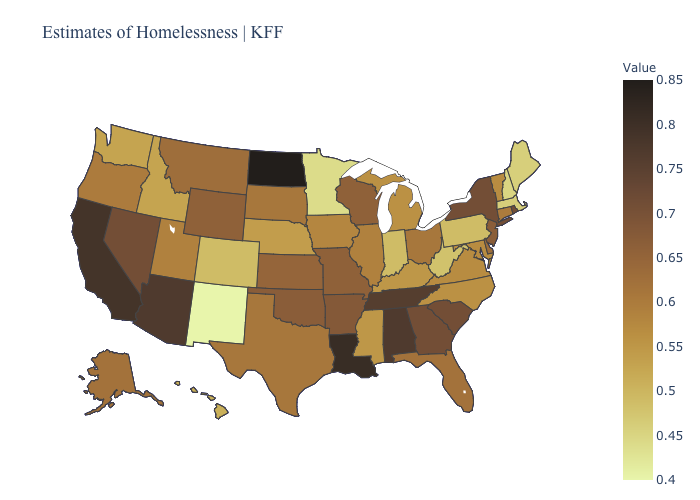Does Illinois have a lower value than Nebraska?
Keep it brief. No. Does the map have missing data?
Concise answer only. No. Is the legend a continuous bar?
Concise answer only. Yes. Among the states that border Arkansas , which have the highest value?
Write a very short answer. Louisiana. Does North Dakota have the highest value in the USA?
Be succinct. Yes. Is the legend a continuous bar?
Write a very short answer. Yes. 